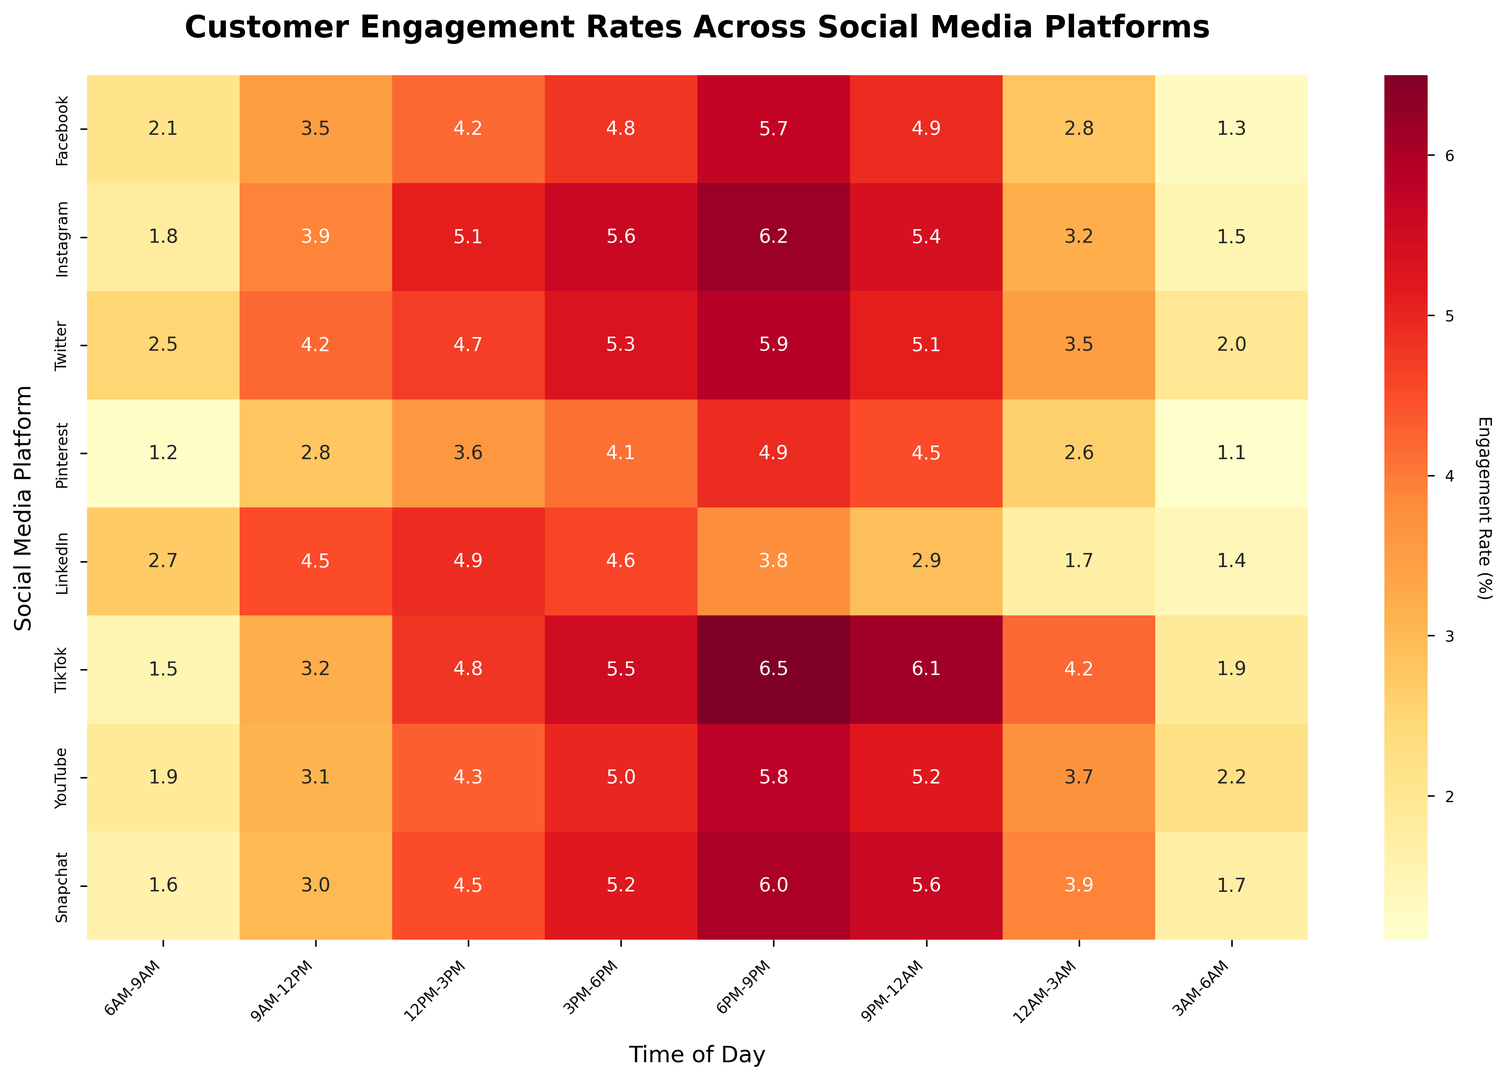What time slot has the highest engagement rate on Instagram? By observing the color intensity and the annotated value for each time slot on Instagram, we can see that the highest engagement rate occurs at 6PM-9PM, which is indicated by the deepest color and the value 6.2.
Answer: 6PM-9PM Which platform has the lowest engagement rate overall during 3PM-6PM? To determine the platform with the lowest engagement during 3PM-6PM, we compare the values in the 3PM-6PM column. Pinterest has the lowest engagement rate of 4.1, which is lower than other platforms’ engagement rates in this time slot.
Answer: Pinterest What are the top two time slots for LinkedIn in terms of engagement rate? By observing the values and colors for LinkedIn across different time slots, the two highest engagement rates are at 9AM-12PM (4.5) and 12PM-3PM (4.9), making them the top two time slots.
Answer: 9AM-12PM, 12PM-3PM How does the engagement rate for Twitter at 9PM-12AM compare to that for Snapchat at the same time? By comparing the values for Twitter and Snapchat at the 9PM-12AM time slot, Twitter has an engagement rate of 5.1, while Snapchat has a slightly higher rate of 5.6.
Answer: Snapchat is higher Which social media platform has the highest engagement rate at 3AM-6AM? By comparing the values in the 3AM-6AM column, YouTube has the highest engagement rate at 2.2, as indicated by the value and the corresponding color intensity.
Answer: YouTube What is the average engagement rate for TikTok between 6PM-9PM and 9PM-12AM? The engagement rates for TikTok in these slots are 6.5 and 6.1, respectively. The average is calculated as (6.5 + 6.1) / 2 = 6.3.
Answer: 6.3 Compare the engagement rates for Facebook and Instagram during 12PM-3PM. Which is higher and by how much? The values for Facebook and Instagram during 12PM-3PM are 4.2 and 5.1, respectively. Instagram's rate is higher by 5.1 - 4.2 = 0.9.
Answer: Instagram by 0.9 What is the overall trend in engagement rates throughout the day for Pinterest? By tracing the values and color gradient for Pinterest from 6AM to 6AM, the engagement rates gradually increase until peaking at 6PM-9PM (4.9) and then gradually decrease, showing a general day-time peak and night-time decline.
Answer: Gradual increase and then decrease During which time slot is the overall engagement rate for all platforms the highest? Summing the engagement rates for each time slot, 6PM-9PM has the highest cumulative rate (5.7+6.2+5.9+4.9+3.8+6.5+5.8+6.0) = 44.8, which is higher than other time slots.
Answer: 6PM-9PM Which two platforms have the closest engagement rates at 6AM-9AM? Comparing the values for each platform at 6AM-9AM, TikTok (1.5) and Instagram (1.8) have the closest engagement rates, with a difference of only 0.3.
Answer: TikTok and Instagram 